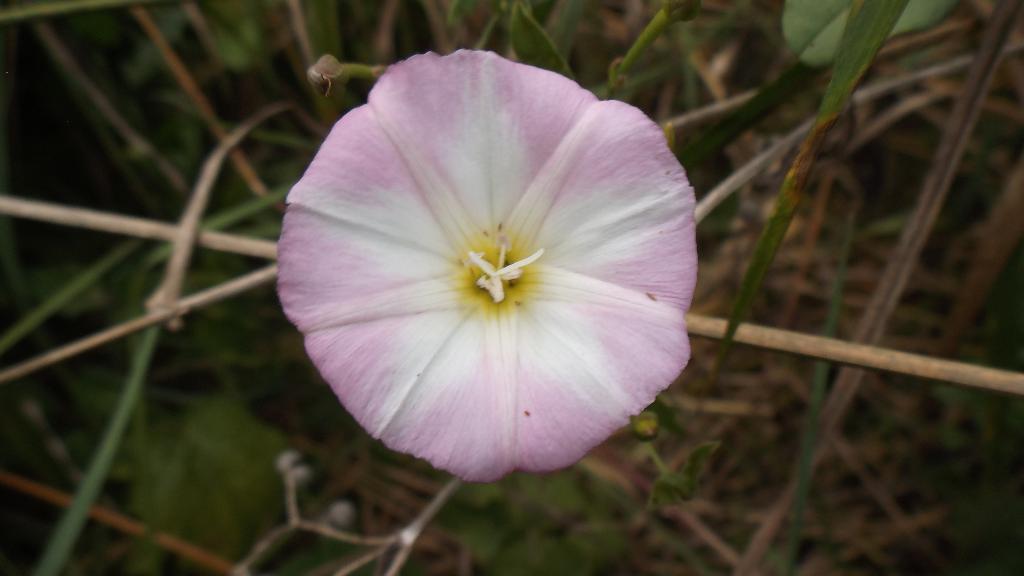Please provide a concise description of this image. In this picture we can see a flower, stems and leaves. 